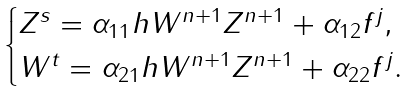<formula> <loc_0><loc_0><loc_500><loc_500>\begin{cases} Z ^ { s } = \alpha _ { 1 1 } h W ^ { n + 1 } Z ^ { n + 1 } + \alpha _ { 1 2 } f ^ { j } , \\ W ^ { t } = \alpha _ { 2 1 } h W ^ { n + 1 } Z ^ { n + 1 } + \alpha _ { 2 2 } f ^ { j } . \end{cases}</formula> 